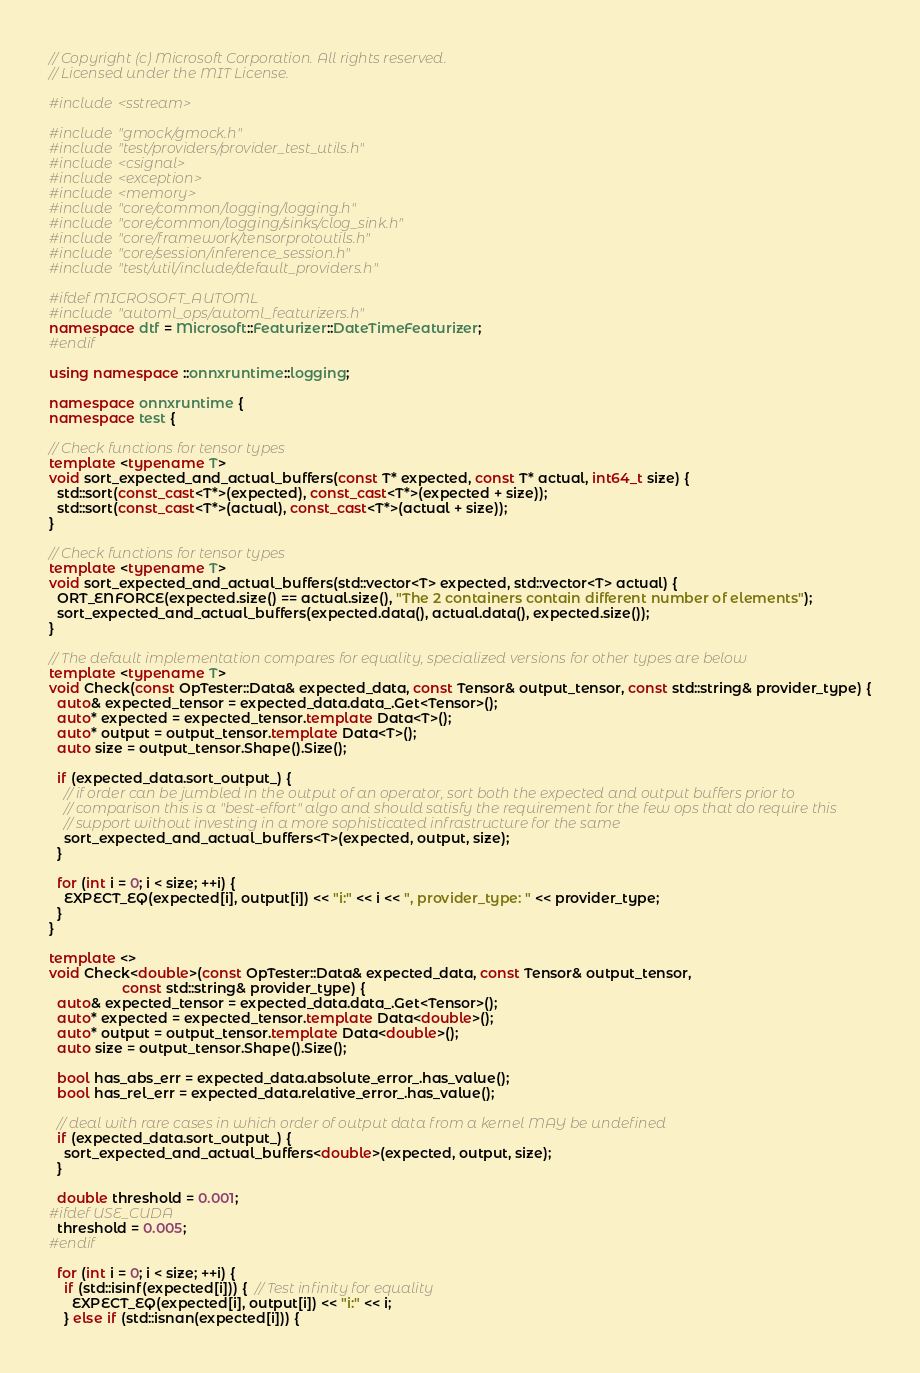Convert code to text. <code><loc_0><loc_0><loc_500><loc_500><_C++_>// Copyright (c) Microsoft Corporation. All rights reserved.
// Licensed under the MIT License.

#include <sstream>

#include "gmock/gmock.h"
#include "test/providers/provider_test_utils.h"
#include <csignal>
#include <exception>
#include <memory>
#include "core/common/logging/logging.h"
#include "core/common/logging/sinks/clog_sink.h"
#include "core/framework/tensorprotoutils.h"
#include "core/session/inference_session.h"
#include "test/util/include/default_providers.h"

#ifdef MICROSOFT_AUTOML
#include "automl_ops/automl_featurizers.h"
namespace dtf = Microsoft::Featurizer::DateTimeFeaturizer;
#endif

using namespace ::onnxruntime::logging;

namespace onnxruntime {
namespace test {

// Check functions for tensor types
template <typename T>
void sort_expected_and_actual_buffers(const T* expected, const T* actual, int64_t size) {
  std::sort(const_cast<T*>(expected), const_cast<T*>(expected + size));
  std::sort(const_cast<T*>(actual), const_cast<T*>(actual + size));
}

// Check functions for tensor types
template <typename T>
void sort_expected_and_actual_buffers(std::vector<T> expected, std::vector<T> actual) {
  ORT_ENFORCE(expected.size() == actual.size(), "The 2 containers contain different number of elements");
  sort_expected_and_actual_buffers(expected.data(), actual.data(), expected.size());
}

// The default implementation compares for equality, specialized versions for other types are below
template <typename T>
void Check(const OpTester::Data& expected_data, const Tensor& output_tensor, const std::string& provider_type) {
  auto& expected_tensor = expected_data.data_.Get<Tensor>();
  auto* expected = expected_tensor.template Data<T>();
  auto* output = output_tensor.template Data<T>();
  auto size = output_tensor.Shape().Size();

  if (expected_data.sort_output_) {
    // if order can be jumbled in the output of an operator, sort both the expected and output buffers prior to
    // comparison this is a "best-effort" algo and should satisfy the requirement for the few ops that do require this
    // support without investing in a more sophisticated infrastructure for the same
    sort_expected_and_actual_buffers<T>(expected, output, size);
  }

  for (int i = 0; i < size; ++i) {
    EXPECT_EQ(expected[i], output[i]) << "i:" << i << ", provider_type: " << provider_type;
  }
}

template <>
void Check<double>(const OpTester::Data& expected_data, const Tensor& output_tensor,
                   const std::string& provider_type) {
  auto& expected_tensor = expected_data.data_.Get<Tensor>();
  auto* expected = expected_tensor.template Data<double>();
  auto* output = output_tensor.template Data<double>();
  auto size = output_tensor.Shape().Size();

  bool has_abs_err = expected_data.absolute_error_.has_value();
  bool has_rel_err = expected_data.relative_error_.has_value();

  // deal with rare cases in which order of output data from a kernel MAY be undefined
  if (expected_data.sort_output_) {
    sort_expected_and_actual_buffers<double>(expected, output, size);
  }

  double threshold = 0.001;
#ifdef USE_CUDA
  threshold = 0.005;
#endif

  for (int i = 0; i < size; ++i) {
    if (std::isinf(expected[i])) {  // Test infinity for equality
      EXPECT_EQ(expected[i], output[i]) << "i:" << i;
    } else if (std::isnan(expected[i])) {</code> 